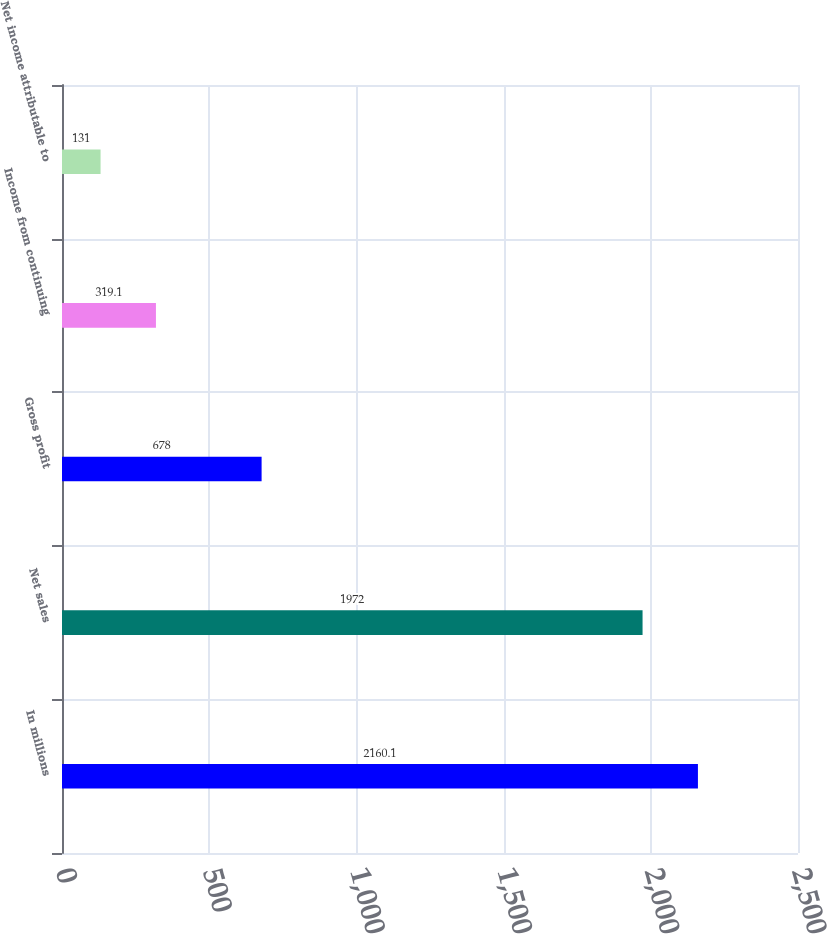Convert chart. <chart><loc_0><loc_0><loc_500><loc_500><bar_chart><fcel>In millions<fcel>Net sales<fcel>Gross profit<fcel>Income from continuing<fcel>Net income attributable to<nl><fcel>2160.1<fcel>1972<fcel>678<fcel>319.1<fcel>131<nl></chart> 